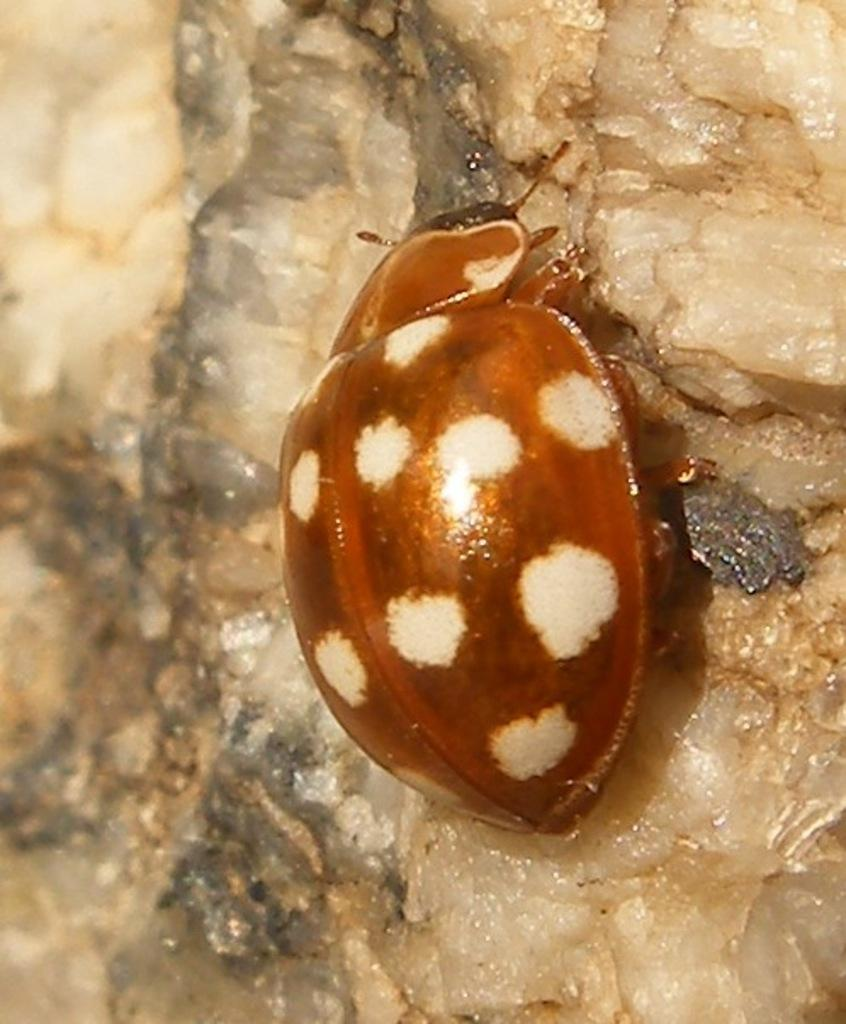What type of insect is in the image? There is a beetle in the image. What is the beetle resting on? The beetle is on a stone. Where is the dog located in the image? There is no dog present in the image. In which direction is the beetle facing in the image? The provided facts do not indicate the direction the beetle is facing. 